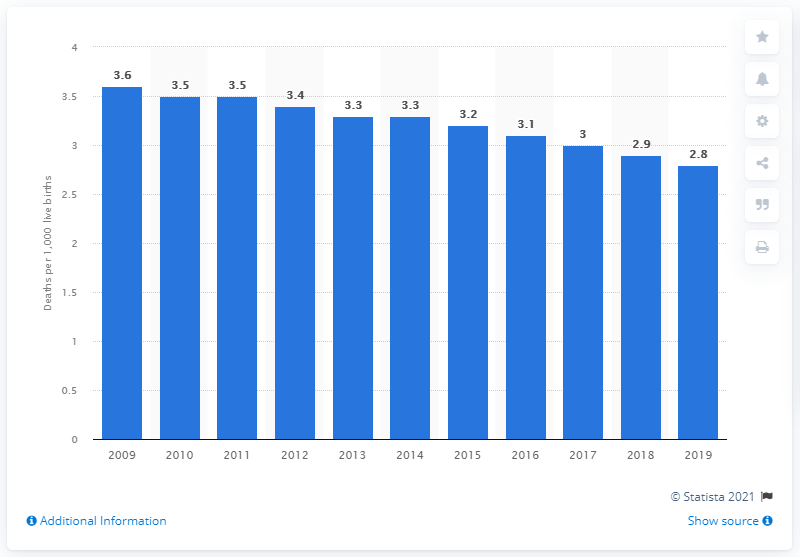Point out several critical features in this image. In 2019, the infant mortality rate in Ireland was 2.8 per 1,000 live births. 